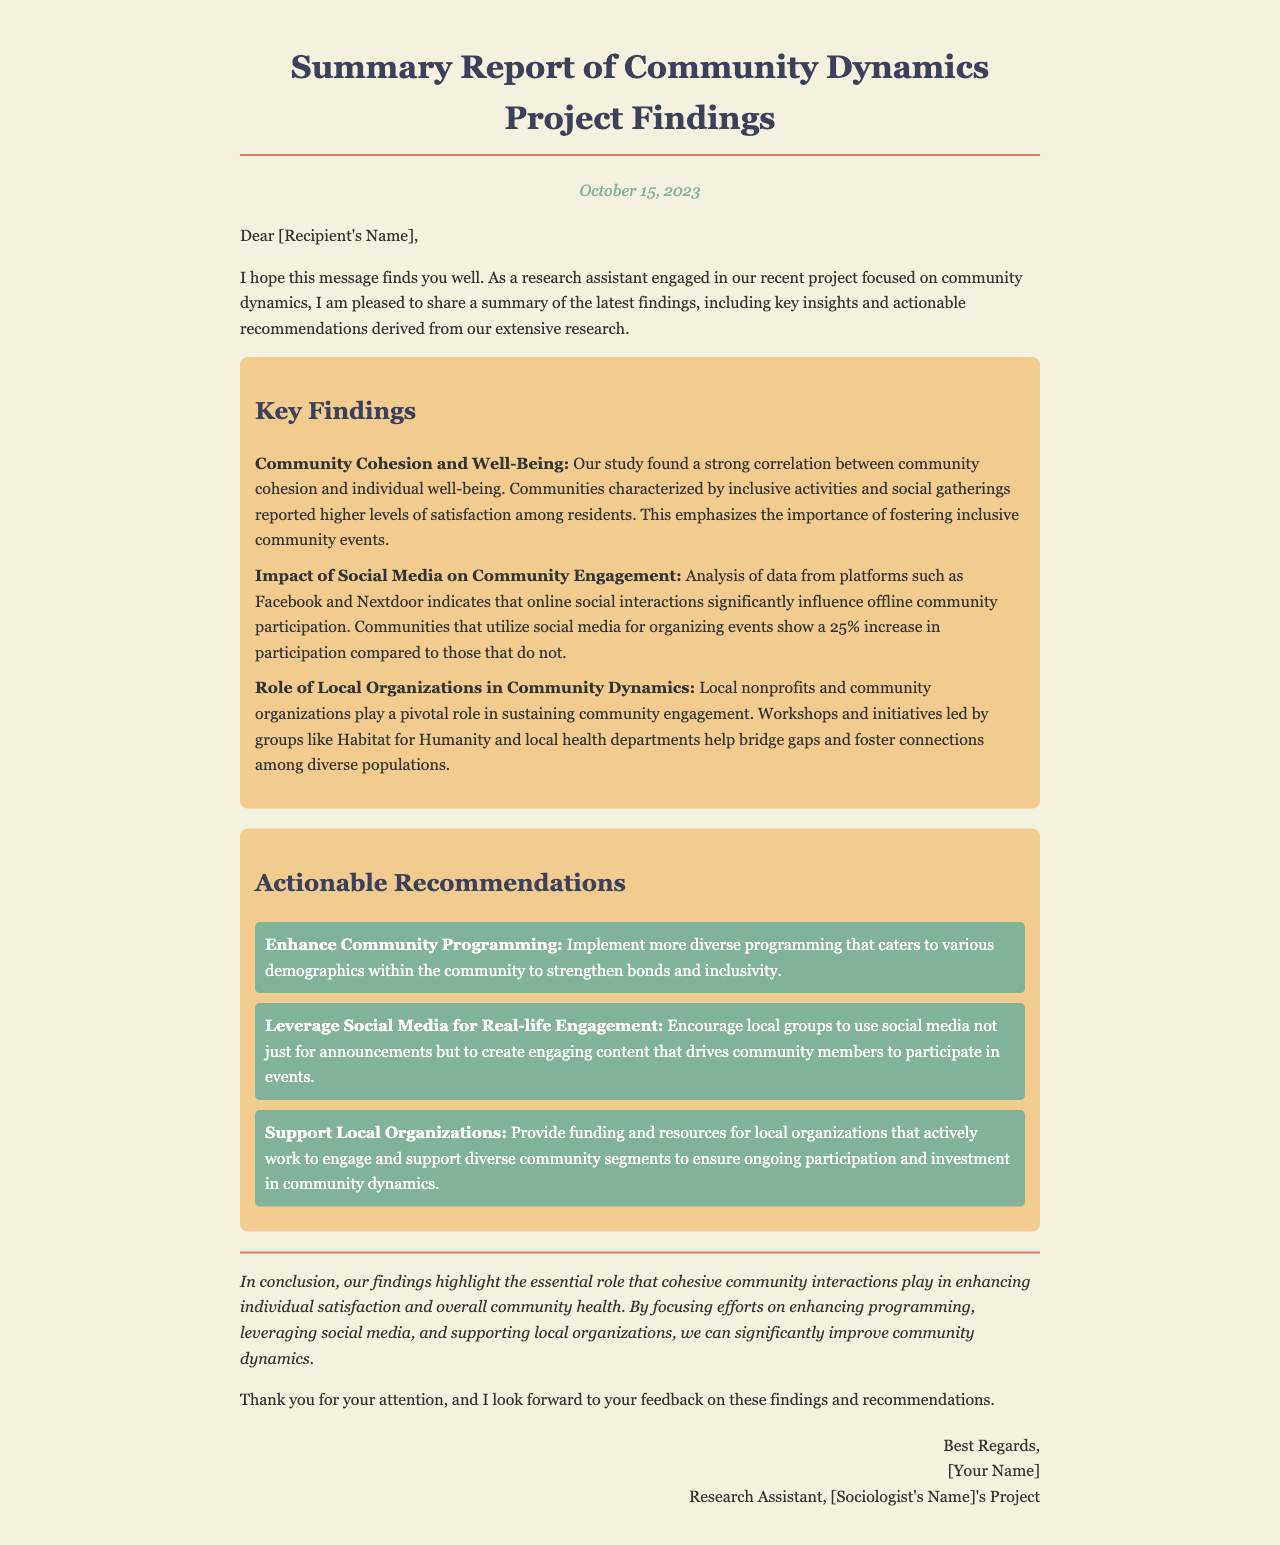What is the date of the report? The report is dated October 15, 2023.
Answer: October 15, 2023 Who authored the report? The report is authored by the research assistant, whose name can be filled in the signature line.
Answer: [Your Name] What is the primary focus of the project? The project focuses on community dynamics as highlighted in the introduction of the letter.
Answer: Community dynamics What percentage increase is noted for communities using social media? The report states there is a 25% increase in participation for communities that utilize social media.
Answer: 25% Which local organization is mentioned as playing a pivotal role? Habitat for Humanity is specifically mentioned as a local organization involved in community engagement efforts.
Answer: Habitat for Humanity What is one actionable recommendation provided? The report suggests enhancing community programming as one of the recommendations.
Answer: Enhance Community Programming What correlation is highlighted in the findings? The findings highlight a correlation between community cohesion and individual well-being.
Answer: Community cohesion and individual well-being What type of events are associated with higher resident satisfaction? Inclusive activities and social gatherings are associated with higher satisfaction among residents.
Answer: Inclusive activities and social gatherings What style of writing is used in the conclusion? The conclusion employs an italic style to emphasize the closing statements of the report.
Answer: Italic style 